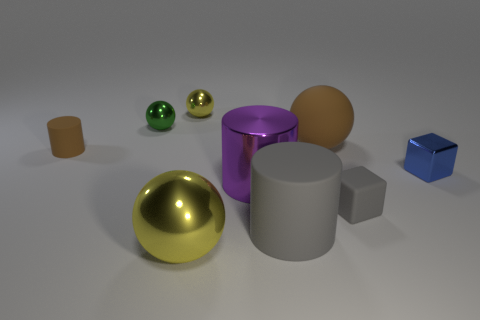Subtract all tiny green metallic spheres. How many spheres are left? 3 Add 1 blue metallic cylinders. How many objects exist? 10 Subtract all purple cylinders. How many cylinders are left? 2 Subtract all purple cylinders. How many yellow balls are left? 2 Subtract all cylinders. How many objects are left? 6 Subtract 1 cylinders. How many cylinders are left? 2 Subtract 0 brown blocks. How many objects are left? 9 Subtract all cyan balls. Subtract all yellow blocks. How many balls are left? 4 Subtract all big yellow shiny balls. Subtract all red matte blocks. How many objects are left? 8 Add 7 yellow balls. How many yellow balls are left? 9 